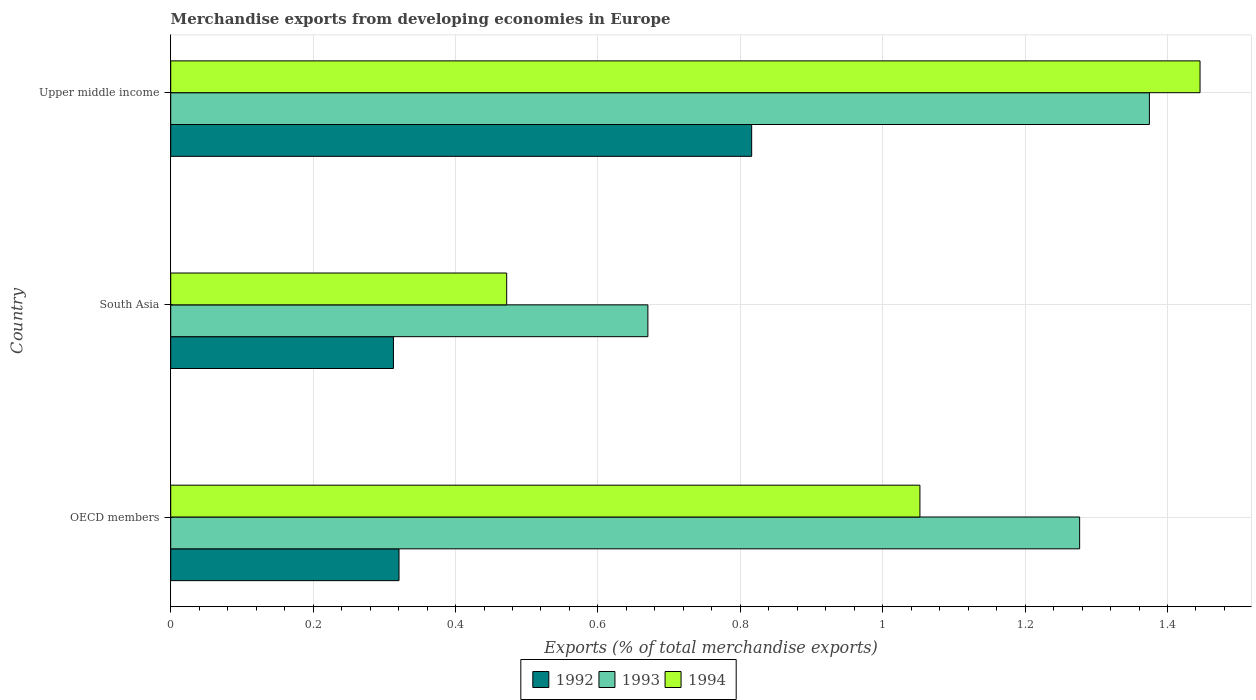How many different coloured bars are there?
Your answer should be very brief. 3. How many groups of bars are there?
Your answer should be compact. 3. What is the label of the 1st group of bars from the top?
Your answer should be compact. Upper middle income. What is the percentage of total merchandise exports in 1993 in South Asia?
Your answer should be compact. 0.67. Across all countries, what is the maximum percentage of total merchandise exports in 1993?
Keep it short and to the point. 1.37. Across all countries, what is the minimum percentage of total merchandise exports in 1993?
Offer a very short reply. 0.67. In which country was the percentage of total merchandise exports in 1994 maximum?
Give a very brief answer. Upper middle income. What is the total percentage of total merchandise exports in 1993 in the graph?
Ensure brevity in your answer.  3.32. What is the difference between the percentage of total merchandise exports in 1992 in South Asia and that in Upper middle income?
Make the answer very short. -0.5. What is the difference between the percentage of total merchandise exports in 1994 in Upper middle income and the percentage of total merchandise exports in 1993 in OECD members?
Provide a succinct answer. 0.17. What is the average percentage of total merchandise exports in 1994 per country?
Your answer should be very brief. 0.99. What is the difference between the percentage of total merchandise exports in 1992 and percentage of total merchandise exports in 1993 in OECD members?
Your answer should be very brief. -0.96. In how many countries, is the percentage of total merchandise exports in 1993 greater than 0.04 %?
Your response must be concise. 3. What is the ratio of the percentage of total merchandise exports in 1994 in South Asia to that in Upper middle income?
Keep it short and to the point. 0.33. Is the percentage of total merchandise exports in 1993 in South Asia less than that in Upper middle income?
Give a very brief answer. Yes. What is the difference between the highest and the second highest percentage of total merchandise exports in 1993?
Offer a terse response. 0.1. What is the difference between the highest and the lowest percentage of total merchandise exports in 1993?
Make the answer very short. 0.7. What does the 1st bar from the top in South Asia represents?
Provide a short and direct response. 1994. What does the 3rd bar from the bottom in OECD members represents?
Offer a very short reply. 1994. How many bars are there?
Your response must be concise. 9. Are all the bars in the graph horizontal?
Give a very brief answer. Yes. Does the graph contain any zero values?
Provide a succinct answer. No. How are the legend labels stacked?
Make the answer very short. Horizontal. What is the title of the graph?
Your response must be concise. Merchandise exports from developing economies in Europe. Does "2009" appear as one of the legend labels in the graph?
Your answer should be very brief. No. What is the label or title of the X-axis?
Give a very brief answer. Exports (% of total merchandise exports). What is the Exports (% of total merchandise exports) of 1992 in OECD members?
Your response must be concise. 0.32. What is the Exports (% of total merchandise exports) of 1993 in OECD members?
Provide a succinct answer. 1.28. What is the Exports (% of total merchandise exports) of 1994 in OECD members?
Provide a succinct answer. 1.05. What is the Exports (% of total merchandise exports) in 1992 in South Asia?
Your response must be concise. 0.31. What is the Exports (% of total merchandise exports) in 1993 in South Asia?
Make the answer very short. 0.67. What is the Exports (% of total merchandise exports) in 1994 in South Asia?
Make the answer very short. 0.47. What is the Exports (% of total merchandise exports) of 1992 in Upper middle income?
Your response must be concise. 0.82. What is the Exports (% of total merchandise exports) of 1993 in Upper middle income?
Your response must be concise. 1.37. What is the Exports (% of total merchandise exports) of 1994 in Upper middle income?
Your answer should be compact. 1.45. Across all countries, what is the maximum Exports (% of total merchandise exports) of 1992?
Make the answer very short. 0.82. Across all countries, what is the maximum Exports (% of total merchandise exports) of 1993?
Make the answer very short. 1.37. Across all countries, what is the maximum Exports (% of total merchandise exports) of 1994?
Your response must be concise. 1.45. Across all countries, what is the minimum Exports (% of total merchandise exports) in 1992?
Your answer should be very brief. 0.31. Across all countries, what is the minimum Exports (% of total merchandise exports) in 1993?
Give a very brief answer. 0.67. Across all countries, what is the minimum Exports (% of total merchandise exports) in 1994?
Your answer should be very brief. 0.47. What is the total Exports (% of total merchandise exports) of 1992 in the graph?
Ensure brevity in your answer.  1.45. What is the total Exports (% of total merchandise exports) in 1993 in the graph?
Give a very brief answer. 3.32. What is the total Exports (% of total merchandise exports) in 1994 in the graph?
Provide a succinct answer. 2.97. What is the difference between the Exports (% of total merchandise exports) of 1992 in OECD members and that in South Asia?
Provide a succinct answer. 0.01. What is the difference between the Exports (% of total merchandise exports) in 1993 in OECD members and that in South Asia?
Offer a very short reply. 0.61. What is the difference between the Exports (% of total merchandise exports) of 1994 in OECD members and that in South Asia?
Give a very brief answer. 0.58. What is the difference between the Exports (% of total merchandise exports) in 1992 in OECD members and that in Upper middle income?
Keep it short and to the point. -0.5. What is the difference between the Exports (% of total merchandise exports) of 1993 in OECD members and that in Upper middle income?
Your response must be concise. -0.1. What is the difference between the Exports (% of total merchandise exports) of 1994 in OECD members and that in Upper middle income?
Give a very brief answer. -0.39. What is the difference between the Exports (% of total merchandise exports) in 1992 in South Asia and that in Upper middle income?
Provide a succinct answer. -0.5. What is the difference between the Exports (% of total merchandise exports) in 1993 in South Asia and that in Upper middle income?
Keep it short and to the point. -0.7. What is the difference between the Exports (% of total merchandise exports) of 1994 in South Asia and that in Upper middle income?
Your response must be concise. -0.97. What is the difference between the Exports (% of total merchandise exports) of 1992 in OECD members and the Exports (% of total merchandise exports) of 1993 in South Asia?
Ensure brevity in your answer.  -0.35. What is the difference between the Exports (% of total merchandise exports) of 1992 in OECD members and the Exports (% of total merchandise exports) of 1994 in South Asia?
Your response must be concise. -0.15. What is the difference between the Exports (% of total merchandise exports) of 1993 in OECD members and the Exports (% of total merchandise exports) of 1994 in South Asia?
Provide a succinct answer. 0.8. What is the difference between the Exports (% of total merchandise exports) in 1992 in OECD members and the Exports (% of total merchandise exports) in 1993 in Upper middle income?
Provide a short and direct response. -1.05. What is the difference between the Exports (% of total merchandise exports) of 1992 in OECD members and the Exports (% of total merchandise exports) of 1994 in Upper middle income?
Make the answer very short. -1.12. What is the difference between the Exports (% of total merchandise exports) in 1993 in OECD members and the Exports (% of total merchandise exports) in 1994 in Upper middle income?
Provide a succinct answer. -0.17. What is the difference between the Exports (% of total merchandise exports) of 1992 in South Asia and the Exports (% of total merchandise exports) of 1993 in Upper middle income?
Your answer should be very brief. -1.06. What is the difference between the Exports (% of total merchandise exports) of 1992 in South Asia and the Exports (% of total merchandise exports) of 1994 in Upper middle income?
Your answer should be compact. -1.13. What is the difference between the Exports (% of total merchandise exports) in 1993 in South Asia and the Exports (% of total merchandise exports) in 1994 in Upper middle income?
Provide a succinct answer. -0.78. What is the average Exports (% of total merchandise exports) in 1992 per country?
Give a very brief answer. 0.48. What is the average Exports (% of total merchandise exports) of 1993 per country?
Ensure brevity in your answer.  1.11. What is the average Exports (% of total merchandise exports) of 1994 per country?
Your answer should be very brief. 0.99. What is the difference between the Exports (% of total merchandise exports) in 1992 and Exports (% of total merchandise exports) in 1993 in OECD members?
Provide a short and direct response. -0.96. What is the difference between the Exports (% of total merchandise exports) in 1992 and Exports (% of total merchandise exports) in 1994 in OECD members?
Offer a terse response. -0.73. What is the difference between the Exports (% of total merchandise exports) in 1993 and Exports (% of total merchandise exports) in 1994 in OECD members?
Give a very brief answer. 0.22. What is the difference between the Exports (% of total merchandise exports) of 1992 and Exports (% of total merchandise exports) of 1993 in South Asia?
Provide a succinct answer. -0.36. What is the difference between the Exports (% of total merchandise exports) in 1992 and Exports (% of total merchandise exports) in 1994 in South Asia?
Provide a short and direct response. -0.16. What is the difference between the Exports (% of total merchandise exports) of 1993 and Exports (% of total merchandise exports) of 1994 in South Asia?
Give a very brief answer. 0.2. What is the difference between the Exports (% of total merchandise exports) in 1992 and Exports (% of total merchandise exports) in 1993 in Upper middle income?
Keep it short and to the point. -0.56. What is the difference between the Exports (% of total merchandise exports) of 1992 and Exports (% of total merchandise exports) of 1994 in Upper middle income?
Offer a terse response. -0.63. What is the difference between the Exports (% of total merchandise exports) in 1993 and Exports (% of total merchandise exports) in 1994 in Upper middle income?
Your answer should be compact. -0.07. What is the ratio of the Exports (% of total merchandise exports) of 1992 in OECD members to that in South Asia?
Your response must be concise. 1.03. What is the ratio of the Exports (% of total merchandise exports) of 1993 in OECD members to that in South Asia?
Offer a very short reply. 1.9. What is the ratio of the Exports (% of total merchandise exports) of 1994 in OECD members to that in South Asia?
Keep it short and to the point. 2.23. What is the ratio of the Exports (% of total merchandise exports) of 1992 in OECD members to that in Upper middle income?
Your answer should be very brief. 0.39. What is the ratio of the Exports (% of total merchandise exports) of 1993 in OECD members to that in Upper middle income?
Keep it short and to the point. 0.93. What is the ratio of the Exports (% of total merchandise exports) in 1994 in OECD members to that in Upper middle income?
Offer a very short reply. 0.73. What is the ratio of the Exports (% of total merchandise exports) in 1992 in South Asia to that in Upper middle income?
Your answer should be compact. 0.38. What is the ratio of the Exports (% of total merchandise exports) in 1993 in South Asia to that in Upper middle income?
Offer a very short reply. 0.49. What is the ratio of the Exports (% of total merchandise exports) in 1994 in South Asia to that in Upper middle income?
Provide a succinct answer. 0.33. What is the difference between the highest and the second highest Exports (% of total merchandise exports) of 1992?
Ensure brevity in your answer.  0.5. What is the difference between the highest and the second highest Exports (% of total merchandise exports) in 1993?
Make the answer very short. 0.1. What is the difference between the highest and the second highest Exports (% of total merchandise exports) in 1994?
Your answer should be compact. 0.39. What is the difference between the highest and the lowest Exports (% of total merchandise exports) in 1992?
Ensure brevity in your answer.  0.5. What is the difference between the highest and the lowest Exports (% of total merchandise exports) of 1993?
Keep it short and to the point. 0.7. What is the difference between the highest and the lowest Exports (% of total merchandise exports) of 1994?
Provide a succinct answer. 0.97. 